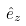<formula> <loc_0><loc_0><loc_500><loc_500>\hat { e } _ { z }</formula> 